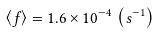<formula> <loc_0><loc_0><loc_500><loc_500>\left \langle f \right \rangle = 1 . 6 \times 1 0 ^ { - 4 } \, \left ( s ^ { - 1 } \right )</formula> 